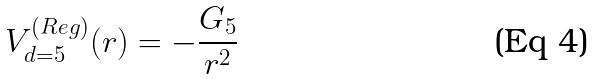<formula> <loc_0><loc_0><loc_500><loc_500>V _ { d = 5 } ^ { ( R e g ) } ( r ) = - \frac { G _ { 5 } } { r ^ { 2 } }</formula> 